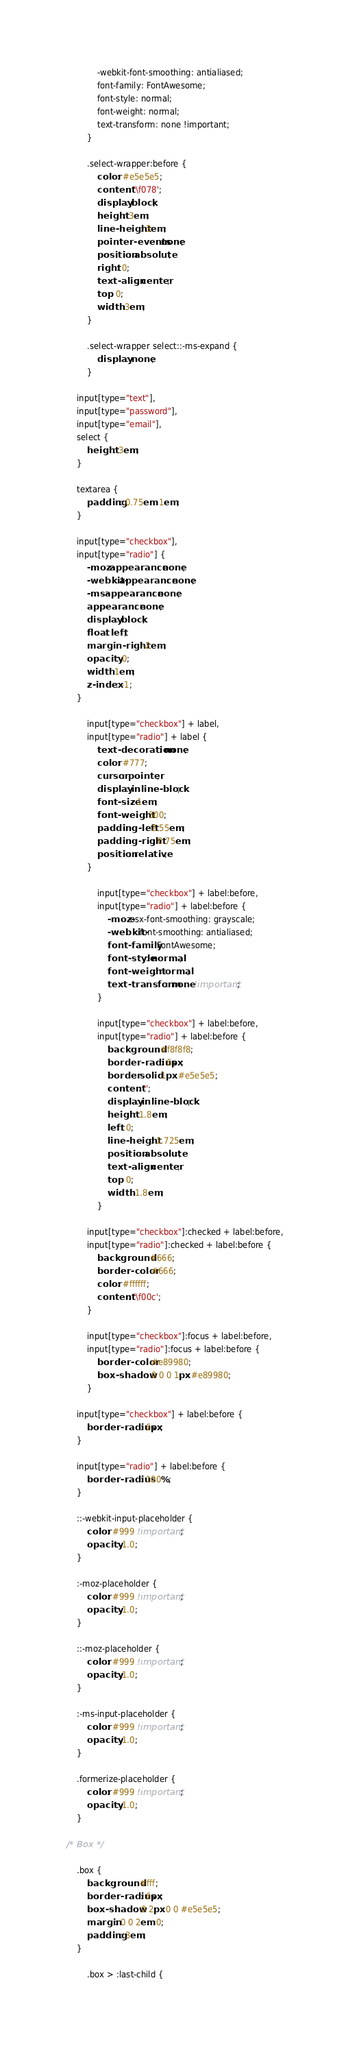<code> <loc_0><loc_0><loc_500><loc_500><_CSS_>			-webkit-font-smoothing: antialiased;
			font-family: FontAwesome;
			font-style: normal;
			font-weight: normal;
			text-transform: none !important;
		}

		.select-wrapper:before {
			color: #e5e5e5;
			content: '\f078';
			display: block;
			height: 3em;
			line-height: 3em;
			pointer-events: none;
			position: absolute;
			right: 0;
			text-align: center;
			top: 0;
			width: 3em;
		}

		.select-wrapper select::-ms-expand {
			display: none;
		}

	input[type="text"],
	input[type="password"],
	input[type="email"],
	select {
		height: 3em;
	}

	textarea {
		padding: 0.75em 1em;
	}

	input[type="checkbox"],
	input[type="radio"] {
		-moz-appearance: none;
		-webkit-appearance: none;
		-ms-appearance: none;
		appearance: none;
		display: block;
		float: left;
		margin-right: -2em;
		opacity: 0;
		width: 1em;
		z-index: -1;
	}

		input[type="checkbox"] + label,
		input[type="radio"] + label {
			text-decoration: none;
			color: #777;
			cursor: pointer;
			display: inline-block;
			font-size: 1em;
			font-weight: 300;
			padding-left: 2.55em;
			padding-right: 0.75em;
			position: relative;
		}

			input[type="checkbox"] + label:before,
			input[type="radio"] + label:before {
				-moz-osx-font-smoothing: grayscale;
				-webkit-font-smoothing: antialiased;
				font-family: FontAwesome;
				font-style: normal;
				font-weight: normal;
				text-transform: none !important;
			}

			input[type="checkbox"] + label:before,
			input[type="radio"] + label:before {
				background: #f8f8f8;
				border-radius: 6px;
				border: solid 1px #e5e5e5;
				content: '';
				display: inline-block;
				height: 1.8em;
				left: 0;
				line-height: 1.725em;
				position: absolute;
				text-align: center;
				top: 0;
				width: 1.8em;
			}

		input[type="checkbox"]:checked + label:before,
		input[type="radio"]:checked + label:before {
			background: #666;
			border-color: #666;
			color: #ffffff;
			content: '\f00c';
		}

		input[type="checkbox"]:focus + label:before,
		input[type="radio"]:focus + label:before {
			border-color: #e89980;
			box-shadow: 0 0 0 1px #e89980;
		}

	input[type="checkbox"] + label:before {
		border-radius: 6px;
	}

	input[type="radio"] + label:before {
		border-radius: 100%;
	}

	::-webkit-input-placeholder {
		color: #999 !important;
		opacity: 1.0;
	}

	:-moz-placeholder {
		color: #999 !important;
		opacity: 1.0;
	}

	::-moz-placeholder {
		color: #999 !important;
		opacity: 1.0;
	}

	:-ms-input-placeholder {
		color: #999 !important;
		opacity: 1.0;
	}

	.formerize-placeholder {
		color: #999 !important;
		opacity: 1.0;
	}

/* Box */

	.box {
		background: #fff;
		border-radius: 6px;
		box-shadow: 0 2px 0 0 #e5e5e5;
		margin: 0 0 2em 0;
		padding: 3em;
	}

		.box > :last-child {</code> 